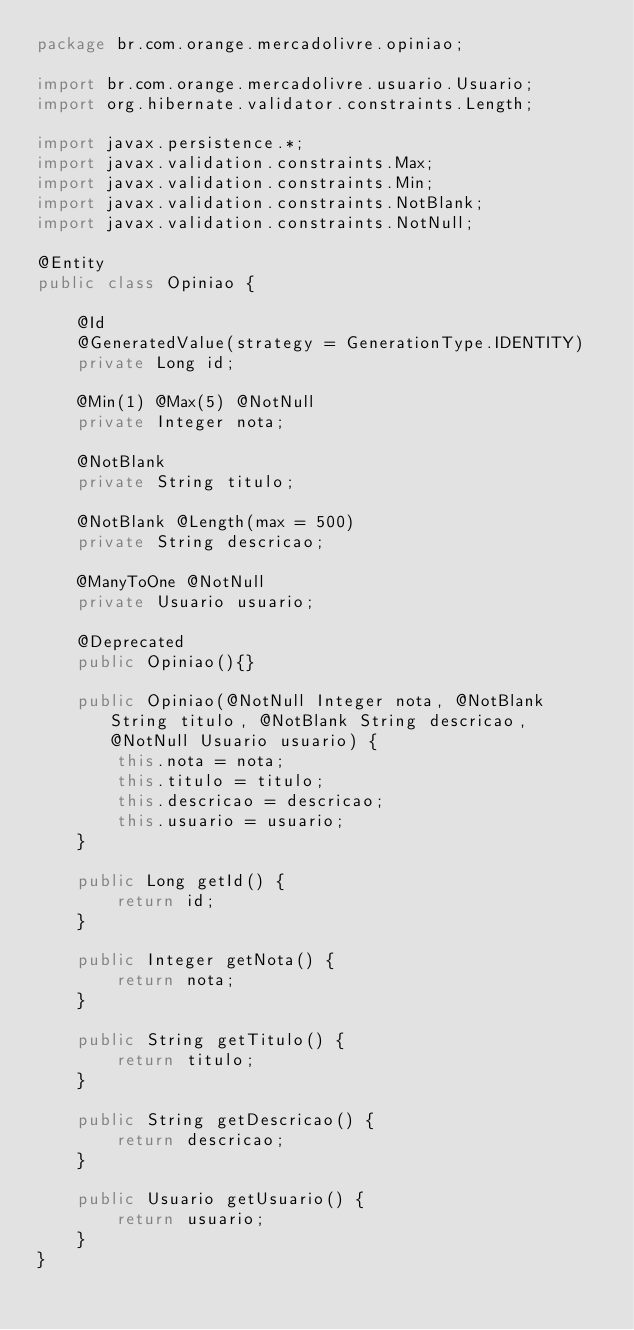Convert code to text. <code><loc_0><loc_0><loc_500><loc_500><_Java_>package br.com.orange.mercadolivre.opiniao;

import br.com.orange.mercadolivre.usuario.Usuario;
import org.hibernate.validator.constraints.Length;

import javax.persistence.*;
import javax.validation.constraints.Max;
import javax.validation.constraints.Min;
import javax.validation.constraints.NotBlank;
import javax.validation.constraints.NotNull;

@Entity
public class Opiniao {

    @Id
    @GeneratedValue(strategy = GenerationType.IDENTITY)
    private Long id;

    @Min(1) @Max(5) @NotNull
    private Integer nota;

    @NotBlank
    private String titulo;

    @NotBlank @Length(max = 500)
    private String descricao;

    @ManyToOne @NotNull
    private Usuario usuario;

    @Deprecated
    public Opiniao(){}

    public Opiniao(@NotNull Integer nota, @NotBlank String titulo, @NotBlank String descricao, @NotNull Usuario usuario) {
        this.nota = nota;
        this.titulo = titulo;
        this.descricao = descricao;
        this.usuario = usuario;
    }

    public Long getId() {
        return id;
    }

    public Integer getNota() {
        return nota;
    }

    public String getTitulo() {
        return titulo;
    }

    public String getDescricao() {
        return descricao;
    }

    public Usuario getUsuario() {
        return usuario;
    }
}
</code> 